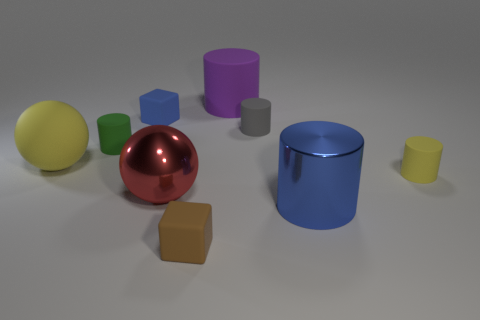What sizes and colors of cylindrical objects can you see in this image? In the image, there are cylindrical objects of varying sizes and colors. Specifically, there is a large blue cylinder, a medium-sized purple cylinder, and a small yellow cylinder. 